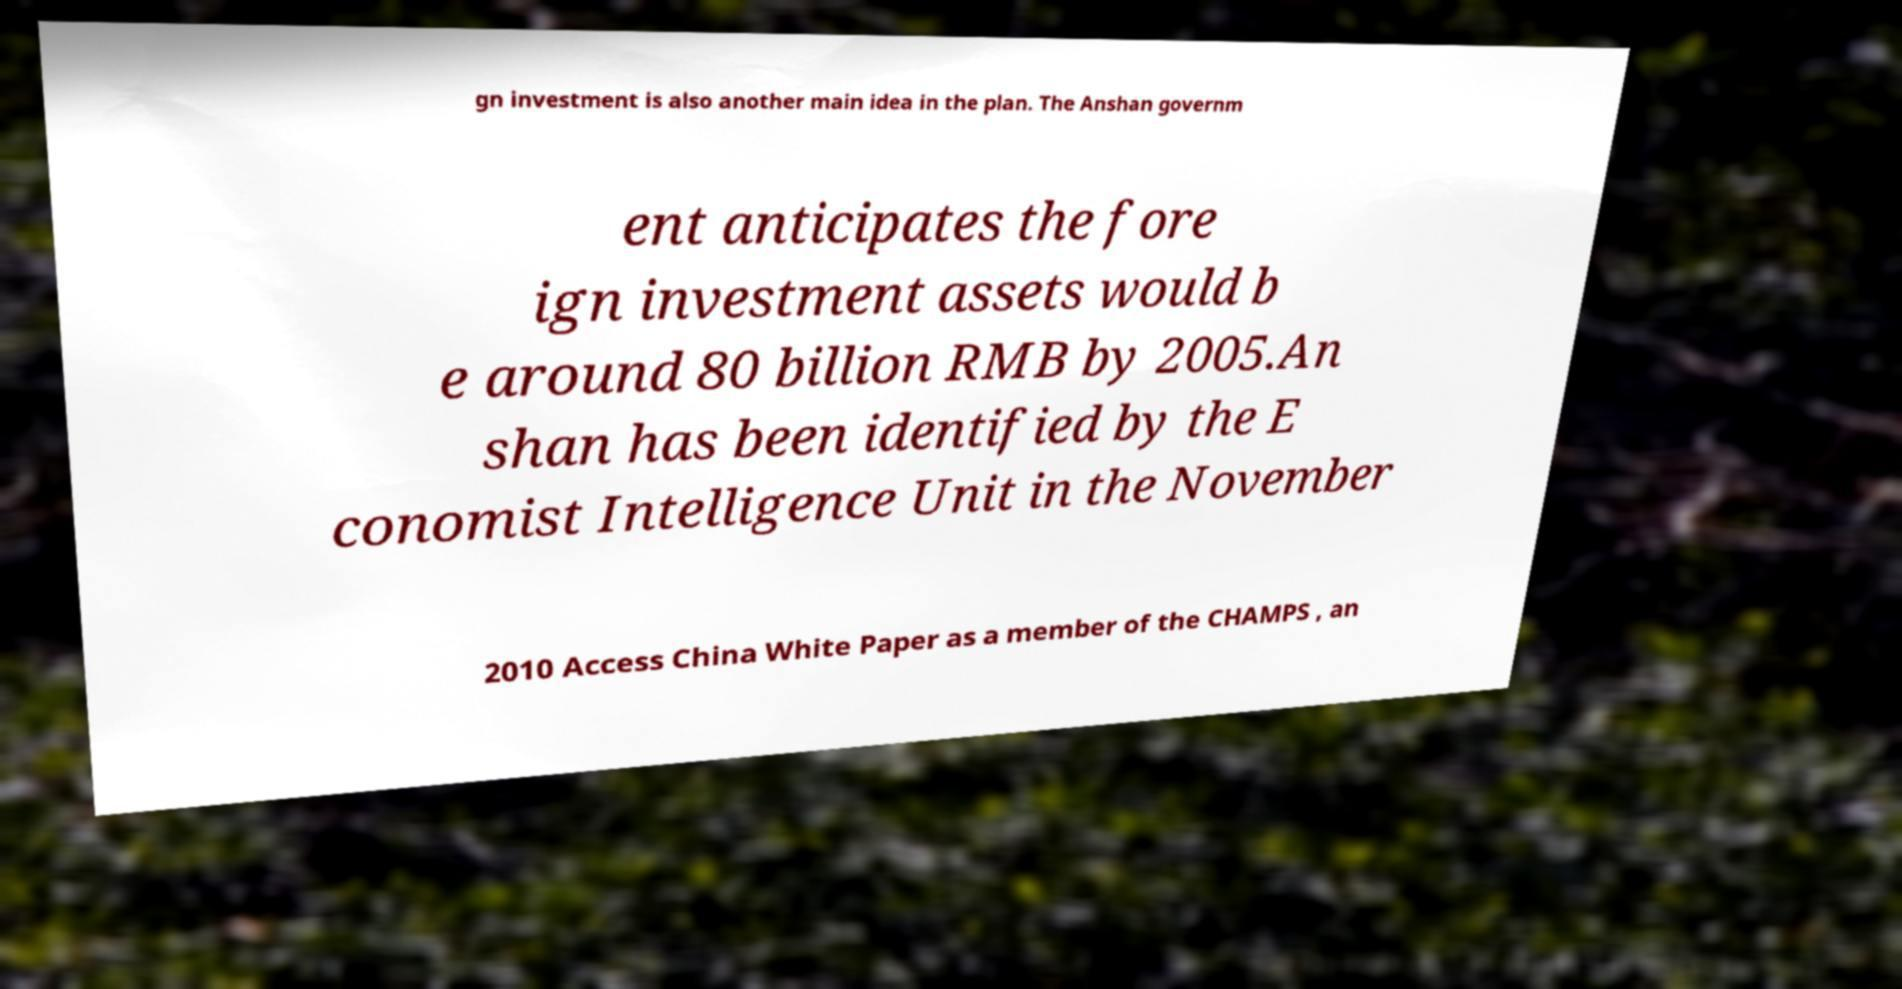For documentation purposes, I need the text within this image transcribed. Could you provide that? gn investment is also another main idea in the plan. The Anshan governm ent anticipates the fore ign investment assets would b e around 80 billion RMB by 2005.An shan has been identified by the E conomist Intelligence Unit in the November 2010 Access China White Paper as a member of the CHAMPS , an 